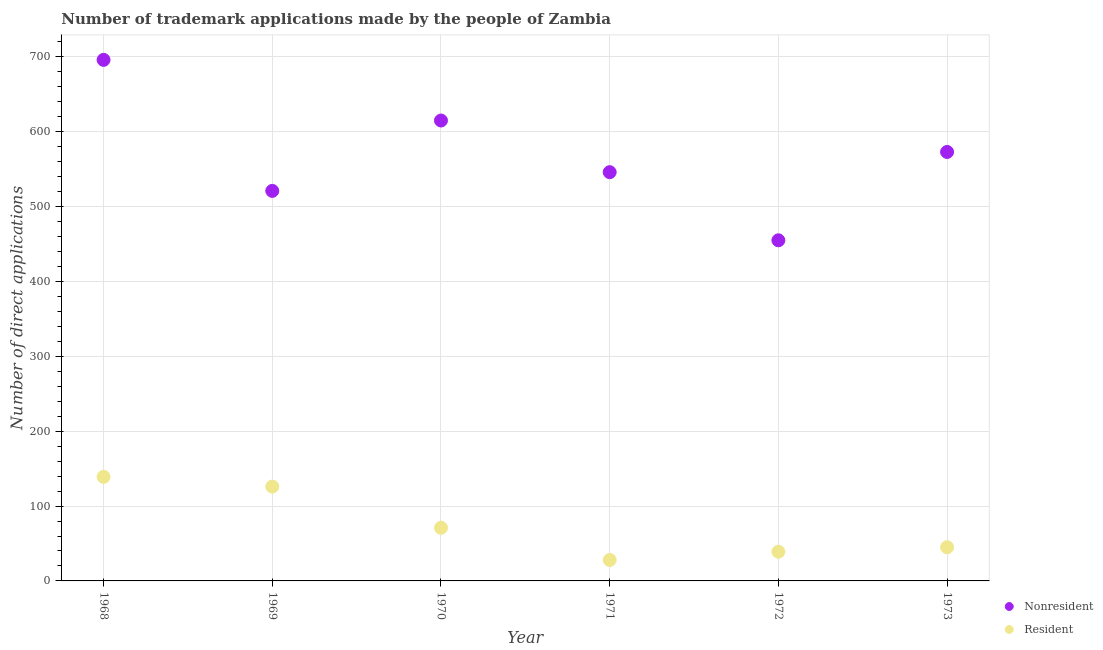How many different coloured dotlines are there?
Give a very brief answer. 2. Is the number of dotlines equal to the number of legend labels?
Ensure brevity in your answer.  Yes. What is the number of trademark applications made by non residents in 1969?
Provide a short and direct response. 521. Across all years, what is the maximum number of trademark applications made by non residents?
Ensure brevity in your answer.  696. Across all years, what is the minimum number of trademark applications made by non residents?
Your answer should be very brief. 455. In which year was the number of trademark applications made by residents maximum?
Provide a short and direct response. 1968. What is the total number of trademark applications made by residents in the graph?
Offer a very short reply. 448. What is the difference between the number of trademark applications made by residents in 1968 and that in 1971?
Your response must be concise. 111. What is the difference between the number of trademark applications made by non residents in 1973 and the number of trademark applications made by residents in 1971?
Offer a terse response. 545. What is the average number of trademark applications made by residents per year?
Provide a short and direct response. 74.67. In the year 1969, what is the difference between the number of trademark applications made by residents and number of trademark applications made by non residents?
Your response must be concise. -395. In how many years, is the number of trademark applications made by non residents greater than 440?
Give a very brief answer. 6. Is the difference between the number of trademark applications made by non residents in 1968 and 1972 greater than the difference between the number of trademark applications made by residents in 1968 and 1972?
Your response must be concise. Yes. What is the difference between the highest and the second highest number of trademark applications made by non residents?
Provide a short and direct response. 81. What is the difference between the highest and the lowest number of trademark applications made by non residents?
Provide a succinct answer. 241. In how many years, is the number of trademark applications made by residents greater than the average number of trademark applications made by residents taken over all years?
Keep it short and to the point. 2. Is the sum of the number of trademark applications made by non residents in 1968 and 1969 greater than the maximum number of trademark applications made by residents across all years?
Offer a very short reply. Yes. Does the number of trademark applications made by residents monotonically increase over the years?
Your answer should be very brief. No. How many dotlines are there?
Give a very brief answer. 2. Where does the legend appear in the graph?
Make the answer very short. Bottom right. How many legend labels are there?
Your answer should be very brief. 2. What is the title of the graph?
Offer a terse response. Number of trademark applications made by the people of Zambia. What is the label or title of the Y-axis?
Ensure brevity in your answer.  Number of direct applications. What is the Number of direct applications in Nonresident in 1968?
Your answer should be very brief. 696. What is the Number of direct applications of Resident in 1968?
Keep it short and to the point. 139. What is the Number of direct applications of Nonresident in 1969?
Offer a terse response. 521. What is the Number of direct applications in Resident in 1969?
Provide a succinct answer. 126. What is the Number of direct applications of Nonresident in 1970?
Give a very brief answer. 615. What is the Number of direct applications in Resident in 1970?
Your answer should be very brief. 71. What is the Number of direct applications in Nonresident in 1971?
Ensure brevity in your answer.  546. What is the Number of direct applications of Nonresident in 1972?
Your answer should be compact. 455. What is the Number of direct applications in Nonresident in 1973?
Your answer should be compact. 573. Across all years, what is the maximum Number of direct applications in Nonresident?
Ensure brevity in your answer.  696. Across all years, what is the maximum Number of direct applications of Resident?
Keep it short and to the point. 139. Across all years, what is the minimum Number of direct applications of Nonresident?
Your answer should be compact. 455. Across all years, what is the minimum Number of direct applications of Resident?
Keep it short and to the point. 28. What is the total Number of direct applications of Nonresident in the graph?
Offer a terse response. 3406. What is the total Number of direct applications in Resident in the graph?
Keep it short and to the point. 448. What is the difference between the Number of direct applications in Nonresident in 1968 and that in 1969?
Your answer should be very brief. 175. What is the difference between the Number of direct applications in Nonresident in 1968 and that in 1970?
Make the answer very short. 81. What is the difference between the Number of direct applications in Resident in 1968 and that in 1970?
Your answer should be very brief. 68. What is the difference between the Number of direct applications of Nonresident in 1968 and that in 1971?
Make the answer very short. 150. What is the difference between the Number of direct applications of Resident in 1968 and that in 1971?
Offer a very short reply. 111. What is the difference between the Number of direct applications of Nonresident in 1968 and that in 1972?
Your answer should be very brief. 241. What is the difference between the Number of direct applications in Nonresident in 1968 and that in 1973?
Offer a terse response. 123. What is the difference between the Number of direct applications of Resident in 1968 and that in 1973?
Your answer should be very brief. 94. What is the difference between the Number of direct applications of Nonresident in 1969 and that in 1970?
Offer a very short reply. -94. What is the difference between the Number of direct applications of Nonresident in 1969 and that in 1971?
Provide a succinct answer. -25. What is the difference between the Number of direct applications in Resident in 1969 and that in 1971?
Give a very brief answer. 98. What is the difference between the Number of direct applications in Resident in 1969 and that in 1972?
Your answer should be very brief. 87. What is the difference between the Number of direct applications in Nonresident in 1969 and that in 1973?
Keep it short and to the point. -52. What is the difference between the Number of direct applications of Nonresident in 1970 and that in 1971?
Provide a short and direct response. 69. What is the difference between the Number of direct applications in Nonresident in 1970 and that in 1972?
Provide a short and direct response. 160. What is the difference between the Number of direct applications in Resident in 1970 and that in 1972?
Your answer should be very brief. 32. What is the difference between the Number of direct applications of Nonresident in 1971 and that in 1972?
Keep it short and to the point. 91. What is the difference between the Number of direct applications of Resident in 1971 and that in 1973?
Offer a very short reply. -17. What is the difference between the Number of direct applications in Nonresident in 1972 and that in 1973?
Your answer should be very brief. -118. What is the difference between the Number of direct applications in Nonresident in 1968 and the Number of direct applications in Resident in 1969?
Offer a terse response. 570. What is the difference between the Number of direct applications in Nonresident in 1968 and the Number of direct applications in Resident in 1970?
Provide a short and direct response. 625. What is the difference between the Number of direct applications of Nonresident in 1968 and the Number of direct applications of Resident in 1971?
Make the answer very short. 668. What is the difference between the Number of direct applications of Nonresident in 1968 and the Number of direct applications of Resident in 1972?
Give a very brief answer. 657. What is the difference between the Number of direct applications of Nonresident in 1968 and the Number of direct applications of Resident in 1973?
Provide a succinct answer. 651. What is the difference between the Number of direct applications in Nonresident in 1969 and the Number of direct applications in Resident in 1970?
Ensure brevity in your answer.  450. What is the difference between the Number of direct applications of Nonresident in 1969 and the Number of direct applications of Resident in 1971?
Give a very brief answer. 493. What is the difference between the Number of direct applications of Nonresident in 1969 and the Number of direct applications of Resident in 1972?
Ensure brevity in your answer.  482. What is the difference between the Number of direct applications in Nonresident in 1969 and the Number of direct applications in Resident in 1973?
Keep it short and to the point. 476. What is the difference between the Number of direct applications of Nonresident in 1970 and the Number of direct applications of Resident in 1971?
Your answer should be very brief. 587. What is the difference between the Number of direct applications in Nonresident in 1970 and the Number of direct applications in Resident in 1972?
Offer a very short reply. 576. What is the difference between the Number of direct applications of Nonresident in 1970 and the Number of direct applications of Resident in 1973?
Offer a very short reply. 570. What is the difference between the Number of direct applications of Nonresident in 1971 and the Number of direct applications of Resident in 1972?
Keep it short and to the point. 507. What is the difference between the Number of direct applications of Nonresident in 1971 and the Number of direct applications of Resident in 1973?
Provide a succinct answer. 501. What is the difference between the Number of direct applications of Nonresident in 1972 and the Number of direct applications of Resident in 1973?
Make the answer very short. 410. What is the average Number of direct applications in Nonresident per year?
Make the answer very short. 567.67. What is the average Number of direct applications in Resident per year?
Keep it short and to the point. 74.67. In the year 1968, what is the difference between the Number of direct applications in Nonresident and Number of direct applications in Resident?
Provide a succinct answer. 557. In the year 1969, what is the difference between the Number of direct applications of Nonresident and Number of direct applications of Resident?
Offer a very short reply. 395. In the year 1970, what is the difference between the Number of direct applications in Nonresident and Number of direct applications in Resident?
Your answer should be very brief. 544. In the year 1971, what is the difference between the Number of direct applications in Nonresident and Number of direct applications in Resident?
Give a very brief answer. 518. In the year 1972, what is the difference between the Number of direct applications in Nonresident and Number of direct applications in Resident?
Your answer should be compact. 416. In the year 1973, what is the difference between the Number of direct applications of Nonresident and Number of direct applications of Resident?
Ensure brevity in your answer.  528. What is the ratio of the Number of direct applications in Nonresident in 1968 to that in 1969?
Offer a very short reply. 1.34. What is the ratio of the Number of direct applications of Resident in 1968 to that in 1969?
Keep it short and to the point. 1.1. What is the ratio of the Number of direct applications of Nonresident in 1968 to that in 1970?
Make the answer very short. 1.13. What is the ratio of the Number of direct applications of Resident in 1968 to that in 1970?
Provide a short and direct response. 1.96. What is the ratio of the Number of direct applications in Nonresident in 1968 to that in 1971?
Make the answer very short. 1.27. What is the ratio of the Number of direct applications of Resident in 1968 to that in 1971?
Make the answer very short. 4.96. What is the ratio of the Number of direct applications of Nonresident in 1968 to that in 1972?
Offer a very short reply. 1.53. What is the ratio of the Number of direct applications in Resident in 1968 to that in 1972?
Your answer should be very brief. 3.56. What is the ratio of the Number of direct applications of Nonresident in 1968 to that in 1973?
Your answer should be very brief. 1.21. What is the ratio of the Number of direct applications in Resident in 1968 to that in 1973?
Provide a short and direct response. 3.09. What is the ratio of the Number of direct applications of Nonresident in 1969 to that in 1970?
Your response must be concise. 0.85. What is the ratio of the Number of direct applications in Resident in 1969 to that in 1970?
Offer a terse response. 1.77. What is the ratio of the Number of direct applications in Nonresident in 1969 to that in 1971?
Offer a very short reply. 0.95. What is the ratio of the Number of direct applications in Nonresident in 1969 to that in 1972?
Your response must be concise. 1.15. What is the ratio of the Number of direct applications in Resident in 1969 to that in 1972?
Give a very brief answer. 3.23. What is the ratio of the Number of direct applications in Nonresident in 1969 to that in 1973?
Offer a terse response. 0.91. What is the ratio of the Number of direct applications in Nonresident in 1970 to that in 1971?
Your answer should be compact. 1.13. What is the ratio of the Number of direct applications of Resident in 1970 to that in 1971?
Your response must be concise. 2.54. What is the ratio of the Number of direct applications of Nonresident in 1970 to that in 1972?
Keep it short and to the point. 1.35. What is the ratio of the Number of direct applications of Resident in 1970 to that in 1972?
Provide a succinct answer. 1.82. What is the ratio of the Number of direct applications of Nonresident in 1970 to that in 1973?
Offer a terse response. 1.07. What is the ratio of the Number of direct applications in Resident in 1970 to that in 1973?
Provide a short and direct response. 1.58. What is the ratio of the Number of direct applications in Nonresident in 1971 to that in 1972?
Give a very brief answer. 1.2. What is the ratio of the Number of direct applications of Resident in 1971 to that in 1972?
Give a very brief answer. 0.72. What is the ratio of the Number of direct applications of Nonresident in 1971 to that in 1973?
Your response must be concise. 0.95. What is the ratio of the Number of direct applications of Resident in 1971 to that in 1973?
Make the answer very short. 0.62. What is the ratio of the Number of direct applications in Nonresident in 1972 to that in 1973?
Your answer should be very brief. 0.79. What is the ratio of the Number of direct applications in Resident in 1972 to that in 1973?
Your answer should be compact. 0.87. What is the difference between the highest and the second highest Number of direct applications in Nonresident?
Ensure brevity in your answer.  81. What is the difference between the highest and the second highest Number of direct applications in Resident?
Make the answer very short. 13. What is the difference between the highest and the lowest Number of direct applications in Nonresident?
Keep it short and to the point. 241. What is the difference between the highest and the lowest Number of direct applications of Resident?
Provide a succinct answer. 111. 